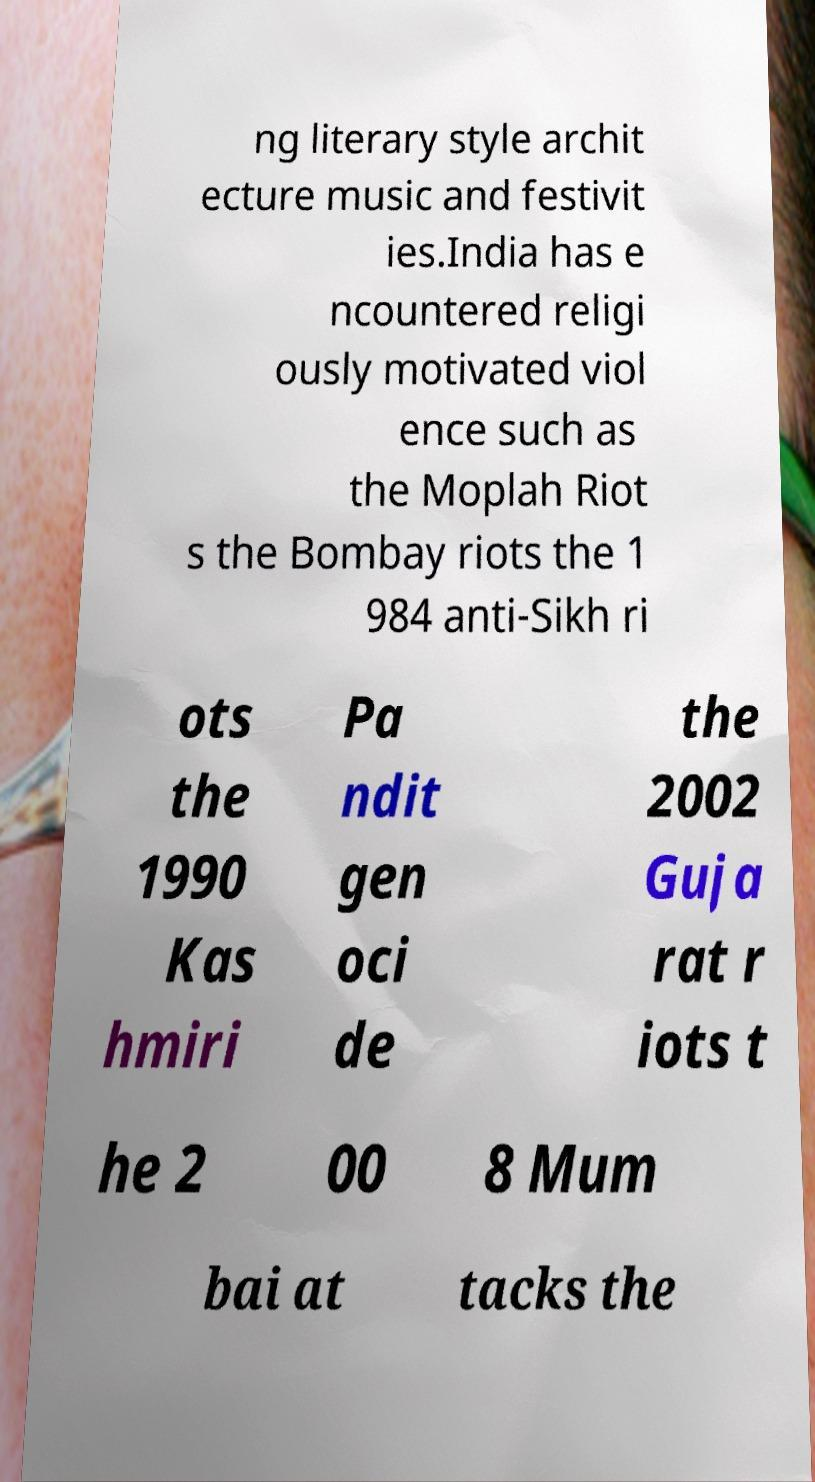For documentation purposes, I need the text within this image transcribed. Could you provide that? ng literary style archit ecture music and festivit ies.India has e ncountered religi ously motivated viol ence such as the Moplah Riot s the Bombay riots the 1 984 anti-Sikh ri ots the 1990 Kas hmiri Pa ndit gen oci de the 2002 Guja rat r iots t he 2 00 8 Mum bai at tacks the 